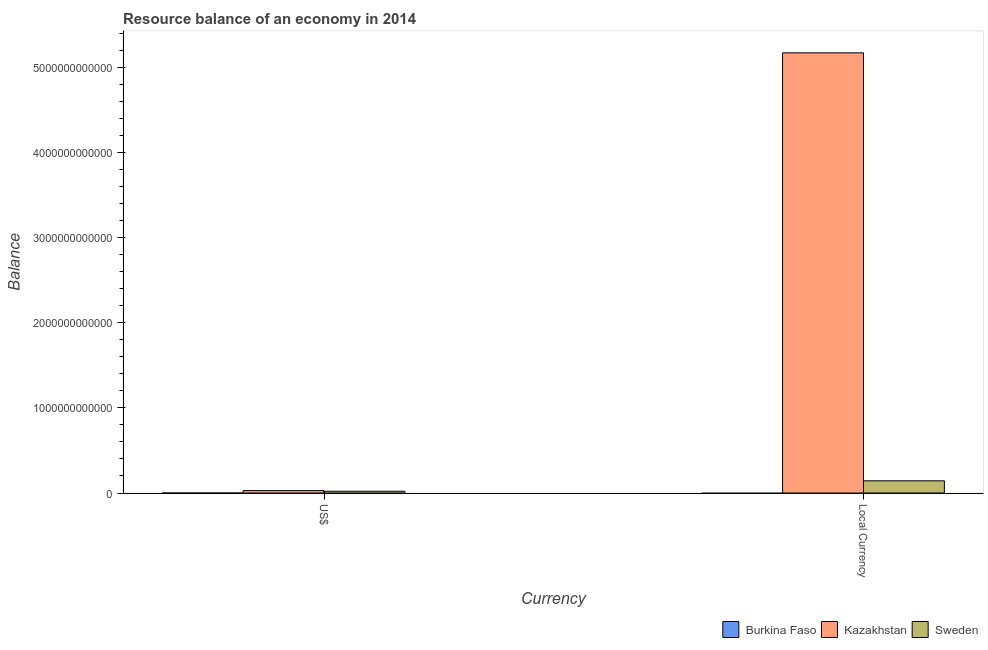Are the number of bars per tick equal to the number of legend labels?
Ensure brevity in your answer.  No. How many bars are there on the 1st tick from the right?
Your answer should be compact. 2. What is the label of the 2nd group of bars from the left?
Provide a succinct answer. Local Currency. What is the resource balance in constant us$ in Burkina Faso?
Keep it short and to the point. 0. Across all countries, what is the maximum resource balance in constant us$?
Provide a succinct answer. 5.17e+12. In which country was the resource balance in constant us$ maximum?
Provide a short and direct response. Kazakhstan. What is the total resource balance in constant us$ in the graph?
Offer a terse response. 5.31e+12. What is the difference between the resource balance in constant us$ in Kazakhstan and that in Sweden?
Offer a terse response. 5.02e+12. What is the difference between the resource balance in us$ in Sweden and the resource balance in constant us$ in Burkina Faso?
Make the answer very short. 2.09e+1. What is the average resource balance in us$ per country?
Ensure brevity in your answer.  1.66e+1. What is the difference between the resource balance in us$ and resource balance in constant us$ in Kazakhstan?
Your response must be concise. -5.14e+12. In how many countries, is the resource balance in us$ greater than 1200000000000 units?
Give a very brief answer. 0. What is the ratio of the resource balance in us$ in Kazakhstan to that in Sweden?
Offer a terse response. 1.38. Is the resource balance in constant us$ in Sweden less than that in Kazakhstan?
Your answer should be very brief. Yes. How many countries are there in the graph?
Ensure brevity in your answer.  3. What is the difference between two consecutive major ticks on the Y-axis?
Provide a short and direct response. 1.00e+12. Does the graph contain any zero values?
Make the answer very short. Yes. Does the graph contain grids?
Ensure brevity in your answer.  No. Where does the legend appear in the graph?
Keep it short and to the point. Bottom right. What is the title of the graph?
Provide a short and direct response. Resource balance of an economy in 2014. Does "Netherlands" appear as one of the legend labels in the graph?
Make the answer very short. No. What is the label or title of the X-axis?
Make the answer very short. Currency. What is the label or title of the Y-axis?
Offer a very short reply. Balance. What is the Balance in Kazakhstan in US$?
Offer a terse response. 2.88e+1. What is the Balance in Sweden in US$?
Give a very brief answer. 2.09e+1. What is the Balance in Kazakhstan in Local Currency?
Your answer should be very brief. 5.17e+12. What is the Balance in Sweden in Local Currency?
Offer a very short reply. 1.43e+11. Across all Currency, what is the maximum Balance in Kazakhstan?
Provide a succinct answer. 5.17e+12. Across all Currency, what is the maximum Balance in Sweden?
Your answer should be compact. 1.43e+11. Across all Currency, what is the minimum Balance in Kazakhstan?
Your response must be concise. 2.88e+1. Across all Currency, what is the minimum Balance of Sweden?
Ensure brevity in your answer.  2.09e+1. What is the total Balance of Burkina Faso in the graph?
Offer a terse response. 0. What is the total Balance of Kazakhstan in the graph?
Give a very brief answer. 5.20e+12. What is the total Balance of Sweden in the graph?
Provide a succinct answer. 1.64e+11. What is the difference between the Balance in Kazakhstan in US$ and that in Local Currency?
Provide a short and direct response. -5.14e+12. What is the difference between the Balance of Sweden in US$ and that in Local Currency?
Keep it short and to the point. -1.22e+11. What is the difference between the Balance of Kazakhstan in US$ and the Balance of Sweden in Local Currency?
Your response must be concise. -1.14e+11. What is the average Balance of Kazakhstan per Currency?
Provide a succinct answer. 2.60e+12. What is the average Balance in Sweden per Currency?
Your answer should be compact. 8.21e+1. What is the difference between the Balance of Kazakhstan and Balance of Sweden in US$?
Provide a short and direct response. 7.95e+09. What is the difference between the Balance of Kazakhstan and Balance of Sweden in Local Currency?
Keep it short and to the point. 5.02e+12. What is the ratio of the Balance of Kazakhstan in US$ to that in Local Currency?
Your response must be concise. 0.01. What is the ratio of the Balance in Sweden in US$ to that in Local Currency?
Your response must be concise. 0.15. What is the difference between the highest and the second highest Balance in Kazakhstan?
Offer a very short reply. 5.14e+12. What is the difference between the highest and the second highest Balance of Sweden?
Give a very brief answer. 1.22e+11. What is the difference between the highest and the lowest Balance in Kazakhstan?
Ensure brevity in your answer.  5.14e+12. What is the difference between the highest and the lowest Balance in Sweden?
Your answer should be compact. 1.22e+11. 